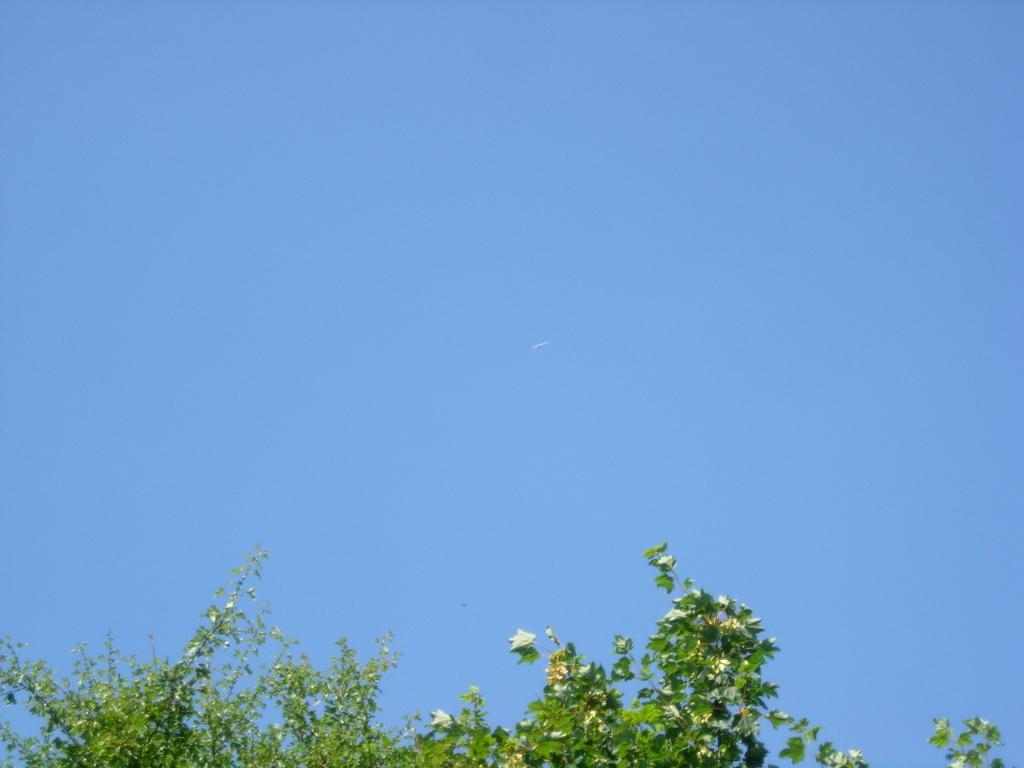What type of vegetation is at the bottom of the image? There are plants at the bottom of the image. What is happening in the sky at the top of the image? There is a bird flying in the sky at the top of the image. What is visible at the top of the image? The sky is visible at the top of the image. Where is the monkey sitting on the stamp in the image? There is no monkey or stamp present in the image. What type of experience can be gained from the image? The image is a visual representation and does not provide an experience. 